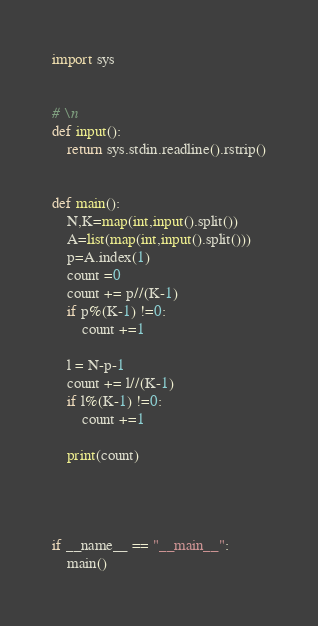<code> <loc_0><loc_0><loc_500><loc_500><_Python_>import sys


# \n
def input():
    return sys.stdin.readline().rstrip()


def main():
    N,K=map(int,input().split())
    A=list(map(int,input().split()))
    p=A.index(1)
    count =0
    count += p//(K-1)
    if p%(K-1) !=0:
        count +=1

    l = N-p-1
    count += l//(K-1)
    if l%(K-1) !=0:
        count +=1

    print(count)




if __name__ == "__main__":
    main()
</code> 